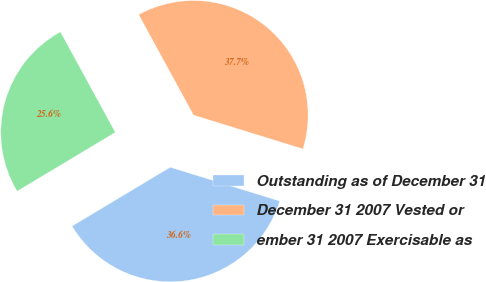Convert chart. <chart><loc_0><loc_0><loc_500><loc_500><pie_chart><fcel>Outstanding as of December 31<fcel>December 31 2007 Vested or<fcel>ember 31 2007 Exercisable as<nl><fcel>36.63%<fcel>37.73%<fcel>25.64%<nl></chart> 